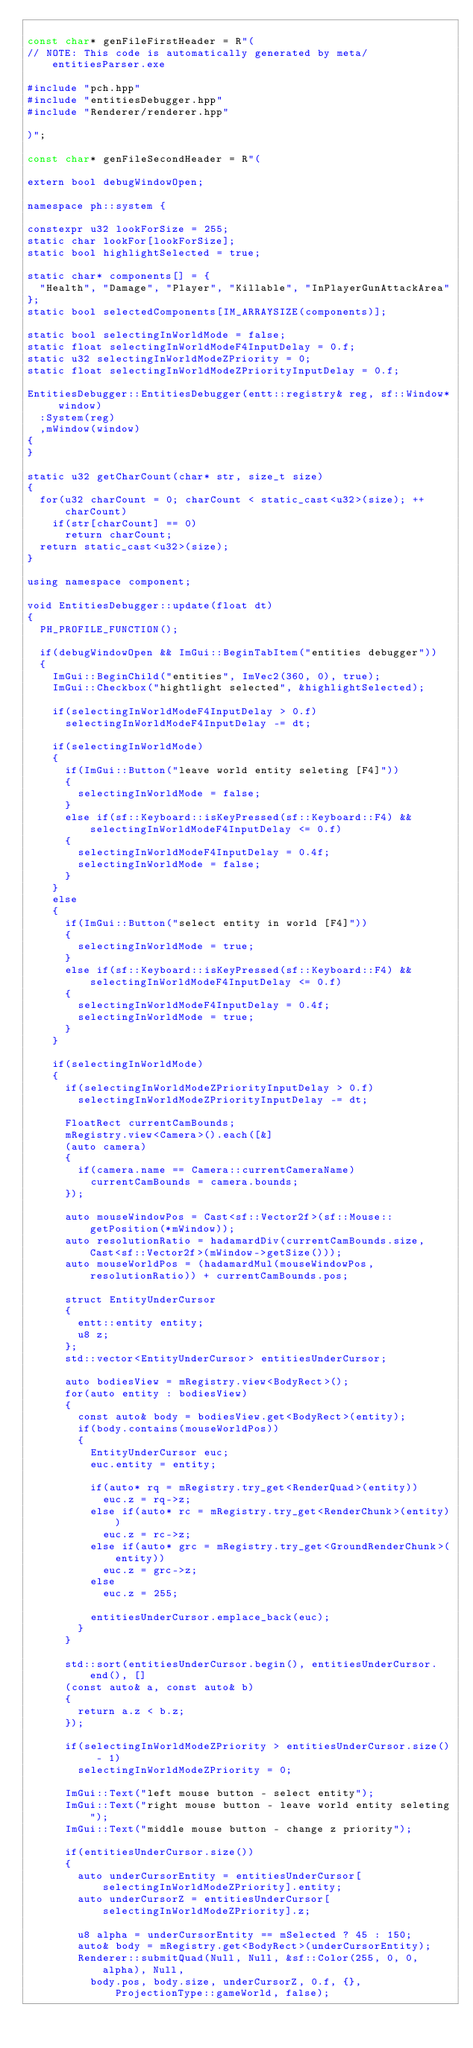Convert code to text. <code><loc_0><loc_0><loc_500><loc_500><_C++_>
const char* genFileFirstHeader = R"(
// NOTE: This code is automatically generated by meta/entitiesParser.exe 

#include "pch.hpp"
#include "entitiesDebugger.hpp"
#include "Renderer/renderer.hpp"

)";

const char* genFileSecondHeader = R"(

extern bool debugWindowOpen;

namespace ph::system {

constexpr u32 lookForSize = 255;
static char lookFor[lookForSize];
static bool highlightSelected = true;

static char* components[] = {
	"Health", "Damage", "Player", "Killable", "InPlayerGunAttackArea"
};
static bool selectedComponents[IM_ARRAYSIZE(components)];

static bool selectingInWorldMode = false;
static float selectingInWorldModeF4InputDelay = 0.f;
static u32 selectingInWorldModeZPriority = 0;
static float selectingInWorldModeZPriorityInputDelay = 0.f;

EntitiesDebugger::EntitiesDebugger(entt::registry& reg, sf::Window* window)
	:System(reg)
	,mWindow(window)
{
}

static u32 getCharCount(char* str, size_t size)
{
	for(u32 charCount = 0; charCount < static_cast<u32>(size); ++charCount)
		if(str[charCount] == 0)
			return charCount;
	return static_cast<u32>(size);
}

using namespace component;

void EntitiesDebugger::update(float dt)
{
	PH_PROFILE_FUNCTION();	

	if(debugWindowOpen && ImGui::BeginTabItem("entities debugger"))
	{
		ImGui::BeginChild("entities", ImVec2(360, 0), true);
		ImGui::Checkbox("hightlight selected", &highlightSelected);

		if(selectingInWorldModeF4InputDelay > 0.f)
			selectingInWorldModeF4InputDelay -= dt;

		if(selectingInWorldMode)
		{
			if(ImGui::Button("leave world entity seleting [F4]"))
			{
				selectingInWorldMode = false;
			}
			else if(sf::Keyboard::isKeyPressed(sf::Keyboard::F4) && selectingInWorldModeF4InputDelay <= 0.f)
			{	
				selectingInWorldModeF4InputDelay = 0.4f;
				selectingInWorldMode = false;
			}
		}
		else
		{
			if(ImGui::Button("select entity in world [F4]"))
			{
				selectingInWorldMode = true;
			}
			else if(sf::Keyboard::isKeyPressed(sf::Keyboard::F4) && selectingInWorldModeF4InputDelay <= 0.f)
			{	
				selectingInWorldModeF4InputDelay = 0.4f;
				selectingInWorldMode = true;
			}
		}

		if(selectingInWorldMode)
		{
			if(selectingInWorldModeZPriorityInputDelay > 0.f)
				selectingInWorldModeZPriorityInputDelay -= dt;

			FloatRect currentCamBounds;
			mRegistry.view<Camera>().each([&]
			(auto camera)
			{
				if(camera.name == Camera::currentCameraName)
					currentCamBounds = camera.bounds;
			});

			auto mouseWindowPos = Cast<sf::Vector2f>(sf::Mouse::getPosition(*mWindow));
			auto resolutionRatio = hadamardDiv(currentCamBounds.size, Cast<sf::Vector2f>(mWindow->getSize()));
			auto mouseWorldPos = (hadamardMul(mouseWindowPos, resolutionRatio)) + currentCamBounds.pos; 

			struct EntityUnderCursor
			{
				entt::entity entity;
				u8 z;
			};
			std::vector<EntityUnderCursor> entitiesUnderCursor;

			auto bodiesView = mRegistry.view<BodyRect>();
			for(auto entity : bodiesView)
			{
				const auto& body = bodiesView.get<BodyRect>(entity); 
				if(body.contains(mouseWorldPos))
				{
					EntityUnderCursor euc;
					euc.entity = entity;

					if(auto* rq = mRegistry.try_get<RenderQuad>(entity))
						euc.z = rq->z; 
					else if(auto* rc = mRegistry.try_get<RenderChunk>(entity))
						euc.z = rc->z;
					else if(auto* grc = mRegistry.try_get<GroundRenderChunk>(entity))
						euc.z = grc->z;
					else
						euc.z = 255;

					entitiesUnderCursor.emplace_back(euc);
				}
			}

			std::sort(entitiesUnderCursor.begin(), entitiesUnderCursor.end(), []
			(const auto& a, const auto& b)
			{
				return a.z < b.z;
			});

			if(selectingInWorldModeZPriority > entitiesUnderCursor.size() - 1)
				selectingInWorldModeZPriority = 0; 

			ImGui::Text("left mouse button - select entity");
			ImGui::Text("right mouse button - leave world entity seleting");
			ImGui::Text("middle mouse button - change z priority");

			if(entitiesUnderCursor.size())
			{
				auto underCursorEntity = entitiesUnderCursor[selectingInWorldModeZPriority].entity;
				auto underCursorZ = entitiesUnderCursor[selectingInWorldModeZPriority].z;

				u8 alpha = underCursorEntity == mSelected ? 45 : 150;
				auto& body = mRegistry.get<BodyRect>(underCursorEntity);
				Renderer::submitQuad(Null, Null, &sf::Color(255, 0, 0, alpha), Null,
					body.pos, body.size, underCursorZ, 0.f, {}, ProjectionType::gameWorld, false);
</code> 